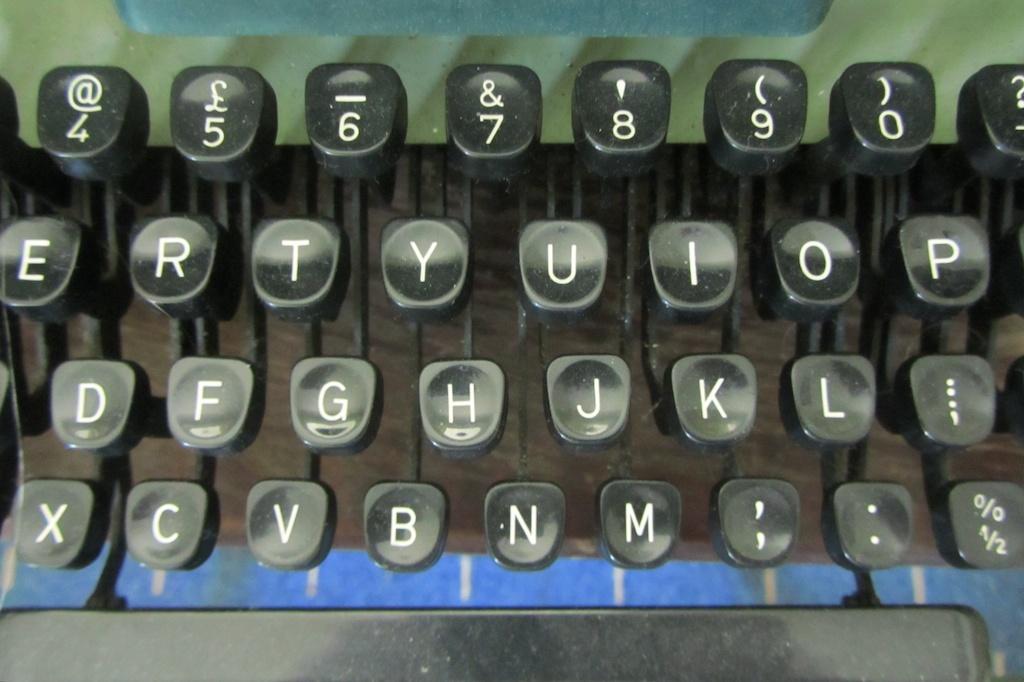What numbers are showing on the keyboard?
Ensure brevity in your answer.  4567890. What is the bottom key on the left?
Provide a succinct answer. X. 